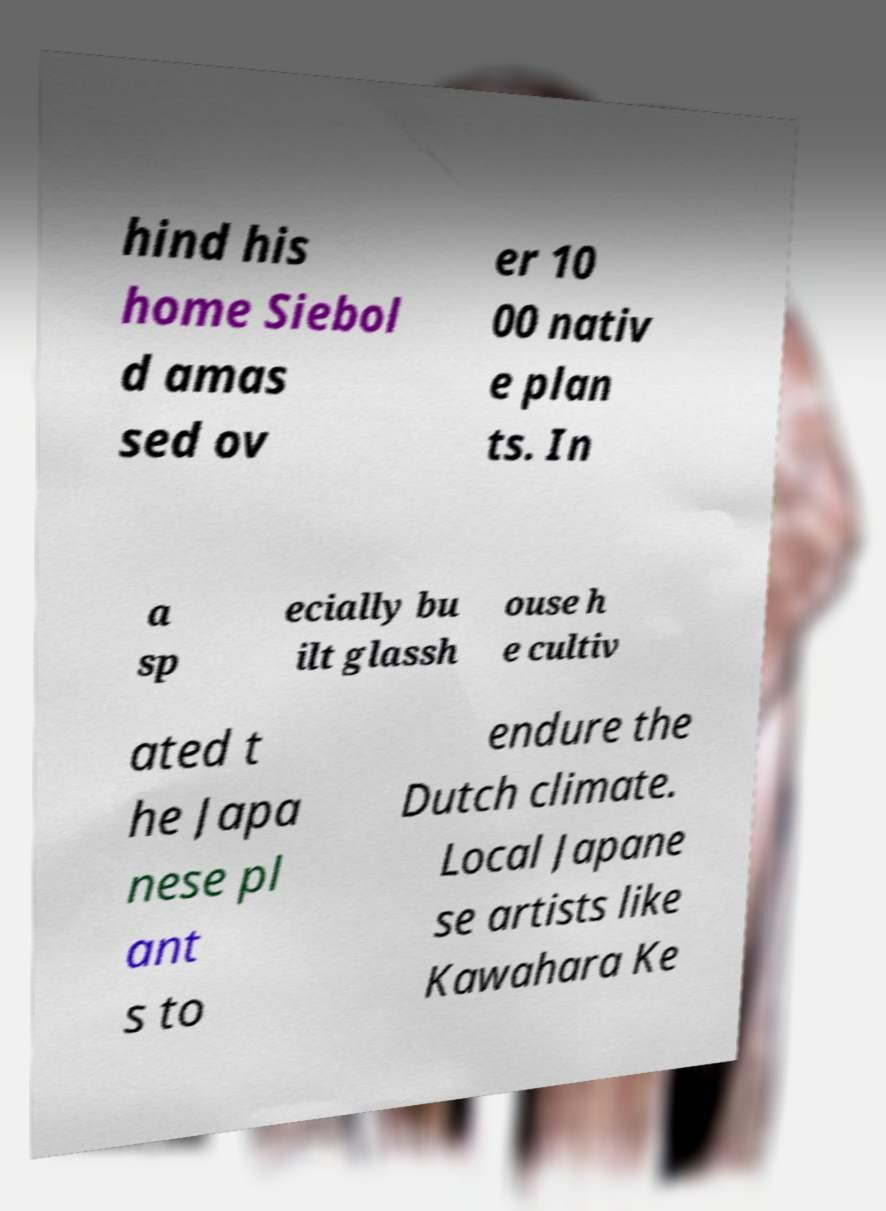What messages or text are displayed in this image? I need them in a readable, typed format. hind his home Siebol d amas sed ov er 10 00 nativ e plan ts. In a sp ecially bu ilt glassh ouse h e cultiv ated t he Japa nese pl ant s to endure the Dutch climate. Local Japane se artists like Kawahara Ke 